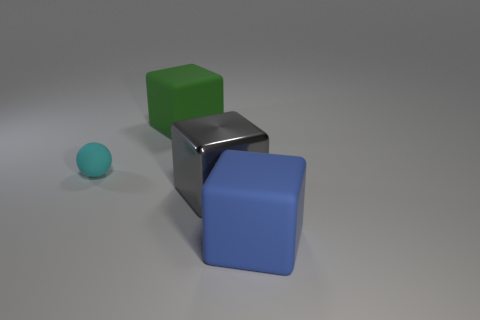Is the number of big green cubes on the right side of the large metal object the same as the number of blue matte cubes in front of the large blue rubber cube?
Your answer should be very brief. Yes. Do the big rubber block that is behind the blue matte thing and the object to the left of the green block have the same color?
Provide a succinct answer. No. Is the number of big blue rubber objects to the right of the blue matte cube greater than the number of gray cubes?
Make the answer very short. No. What is the shape of the small object that is made of the same material as the blue cube?
Make the answer very short. Sphere. There is a rubber block that is on the left side of the blue block; is it the same size as the small cyan rubber thing?
Your response must be concise. No. There is a big matte thing that is behind the big matte thing in front of the big green cube; what is its shape?
Your answer should be very brief. Cube. There is a matte cube that is in front of the large rubber block behind the large blue rubber thing; what size is it?
Ensure brevity in your answer.  Large. There is a big rubber cube behind the cyan rubber object; what color is it?
Keep it short and to the point. Green. The green thing that is the same material as the tiny sphere is what size?
Your response must be concise. Large. How many other tiny things are the same shape as the metal thing?
Your response must be concise. 0. 